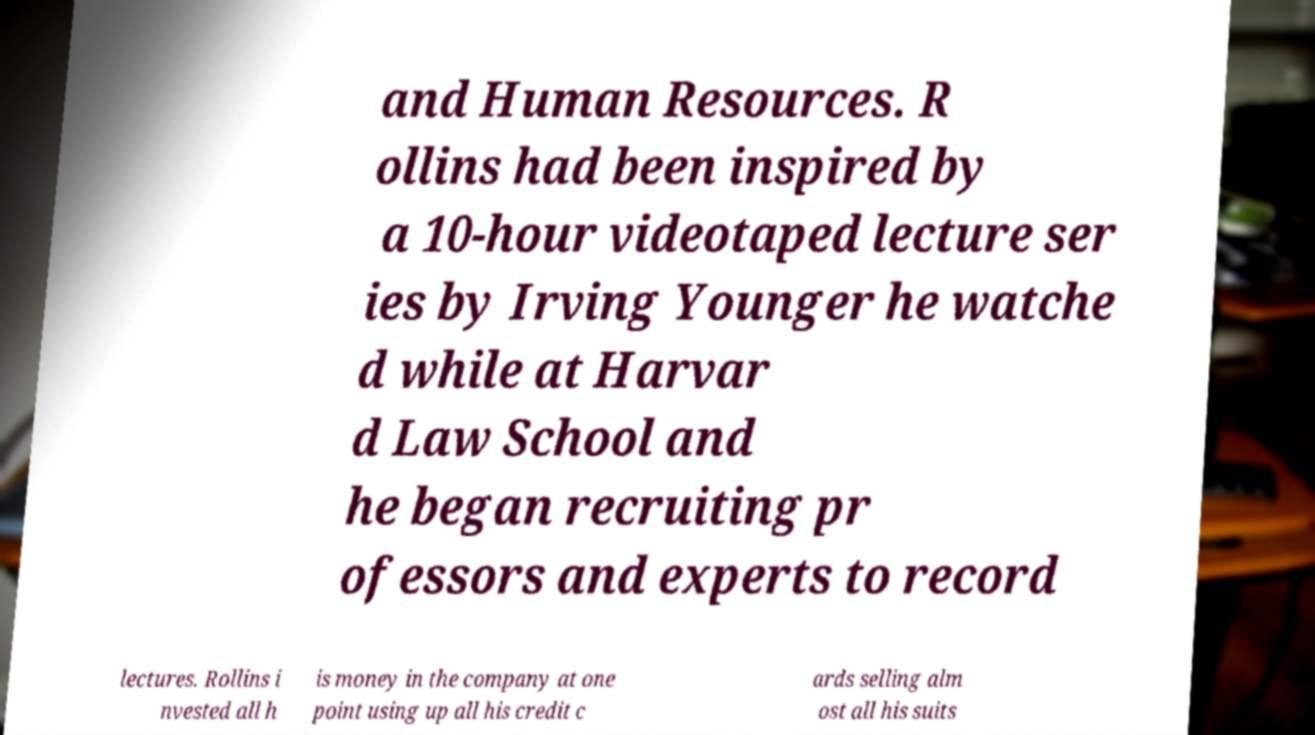I need the written content from this picture converted into text. Can you do that? and Human Resources. R ollins had been inspired by a 10-hour videotaped lecture ser ies by Irving Younger he watche d while at Harvar d Law School and he began recruiting pr ofessors and experts to record lectures. Rollins i nvested all h is money in the company at one point using up all his credit c ards selling alm ost all his suits 